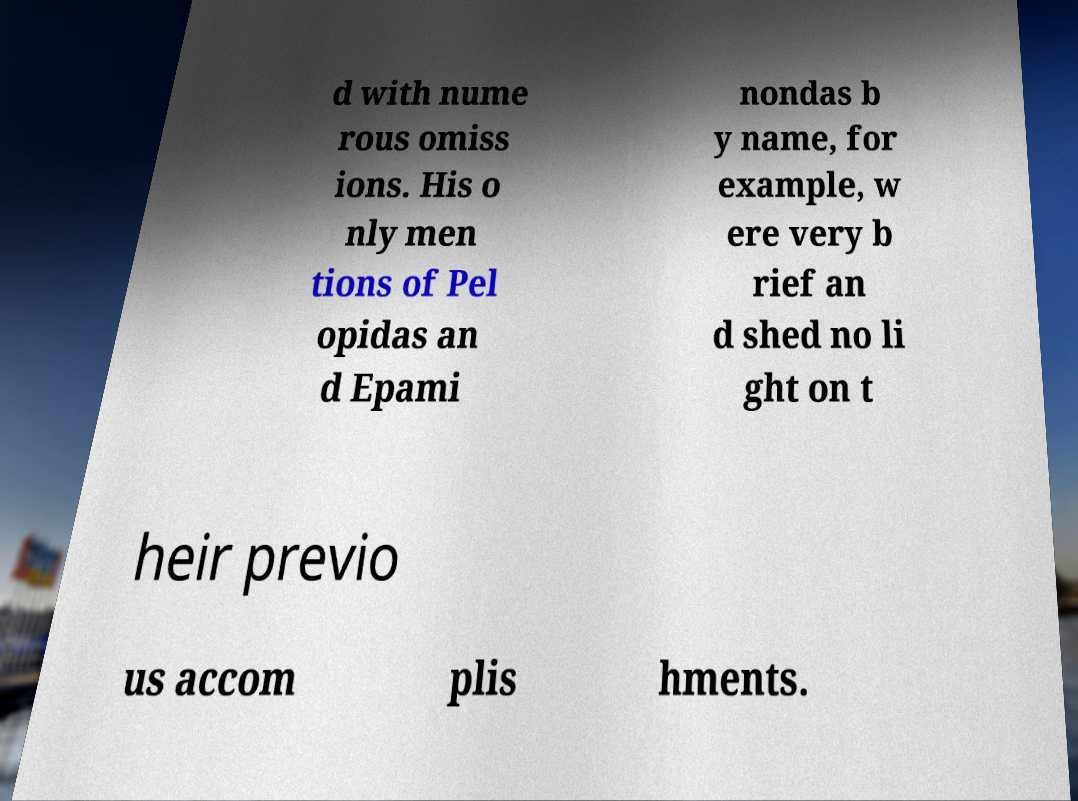Could you assist in decoding the text presented in this image and type it out clearly? d with nume rous omiss ions. His o nly men tions of Pel opidas an d Epami nondas b y name, for example, w ere very b rief an d shed no li ght on t heir previo us accom plis hments. 